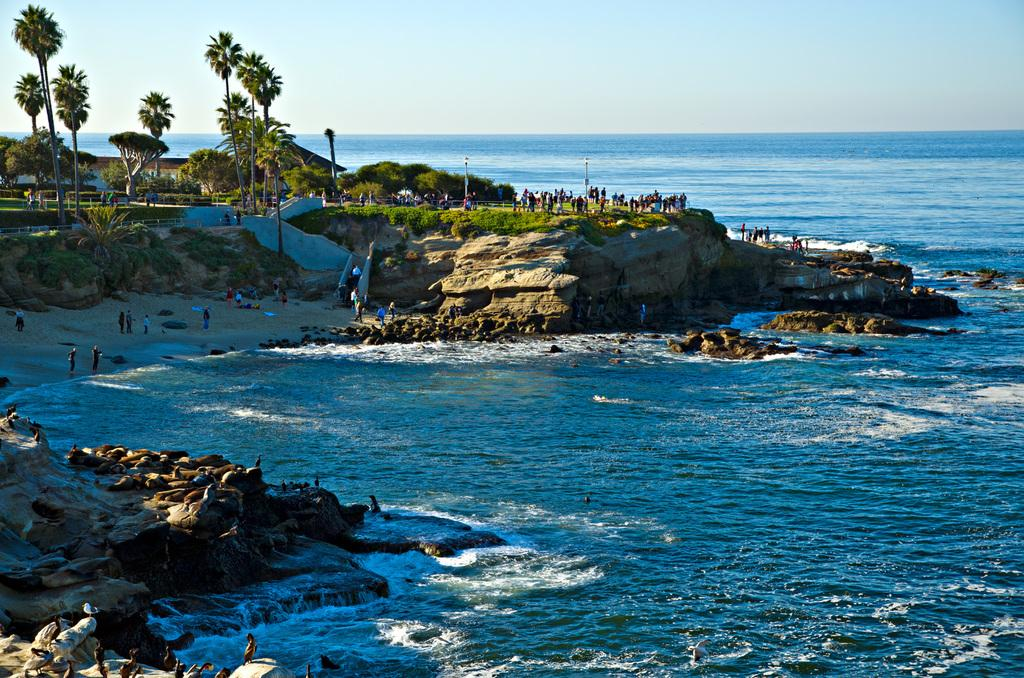Who or what can be seen in the image? There are people in the image. What is the primary element visible in the image? There is water visible in the image. What type of natural features are present in the image? There are rocks in the image. What can be seen in the background of the image? There are trees, poles, and houses in the background of the image. What type of bulb can be seen illuminating the tent in the image? There is no tent or bulb present in the image. What smell can be detected from the image? The image is visual, and there is no way to detect a smell from it. 